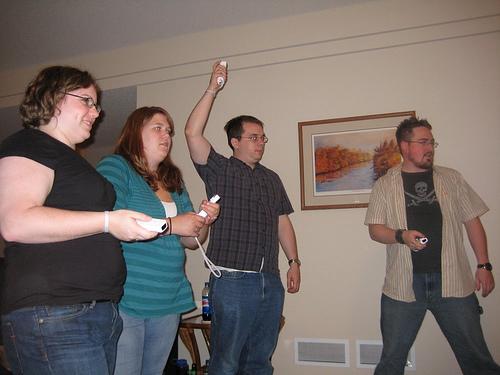What nationality do they look?
Keep it brief. American. Do both men have glasses on?
Quick response, please. Yes. How many people are playing the game?
Give a very brief answer. 4. How many women are playing?
Write a very short answer. 2. Is there a picture on the wall?
Answer briefly. Yes. How many people wearing blue jeans?
Give a very brief answer. 4. What logo is on the man on the left's Jersey?
Quick response, please. Skull. Is the lady playing the game well?
Keep it brief. No. What object is on the wall?
Give a very brief answer. Picture. Is there more men than women in the photo?
Short answer required. No. How many people are standing?
Answer briefly. 4. 